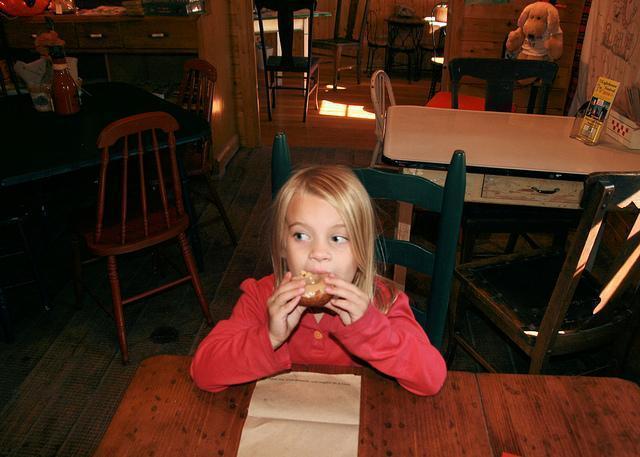How many dining tables are visible?
Give a very brief answer. 3. How many chairs are in the photo?
Give a very brief answer. 7. 